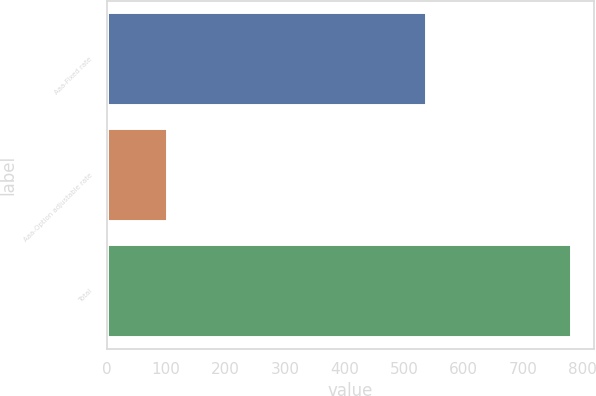Convert chart to OTSL. <chart><loc_0><loc_0><loc_500><loc_500><bar_chart><fcel>Aaa-Fixed rate<fcel>Aaa-Option adjustable rate<fcel>Total<nl><fcel>537<fcel>101<fcel>780<nl></chart> 